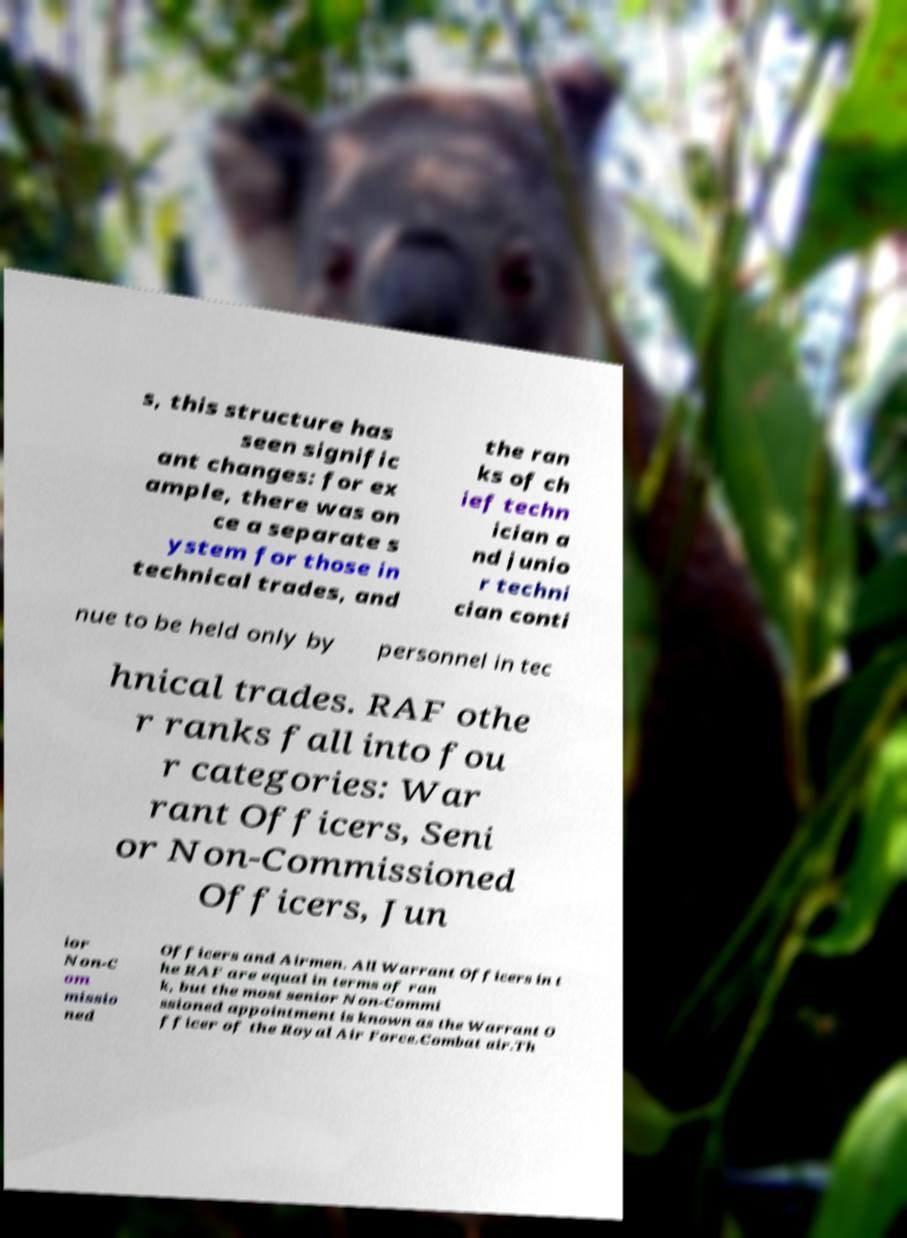Please read and relay the text visible in this image. What does it say? s, this structure has seen signific ant changes: for ex ample, there was on ce a separate s ystem for those in technical trades, and the ran ks of ch ief techn ician a nd junio r techni cian conti nue to be held only by personnel in tec hnical trades. RAF othe r ranks fall into fou r categories: War rant Officers, Seni or Non-Commissioned Officers, Jun ior Non-C om missio ned Officers and Airmen. All Warrant Officers in t he RAF are equal in terms of ran k, but the most senior Non-Commi ssioned appointment is known as the Warrant O fficer of the Royal Air Force.Combat air.Th 